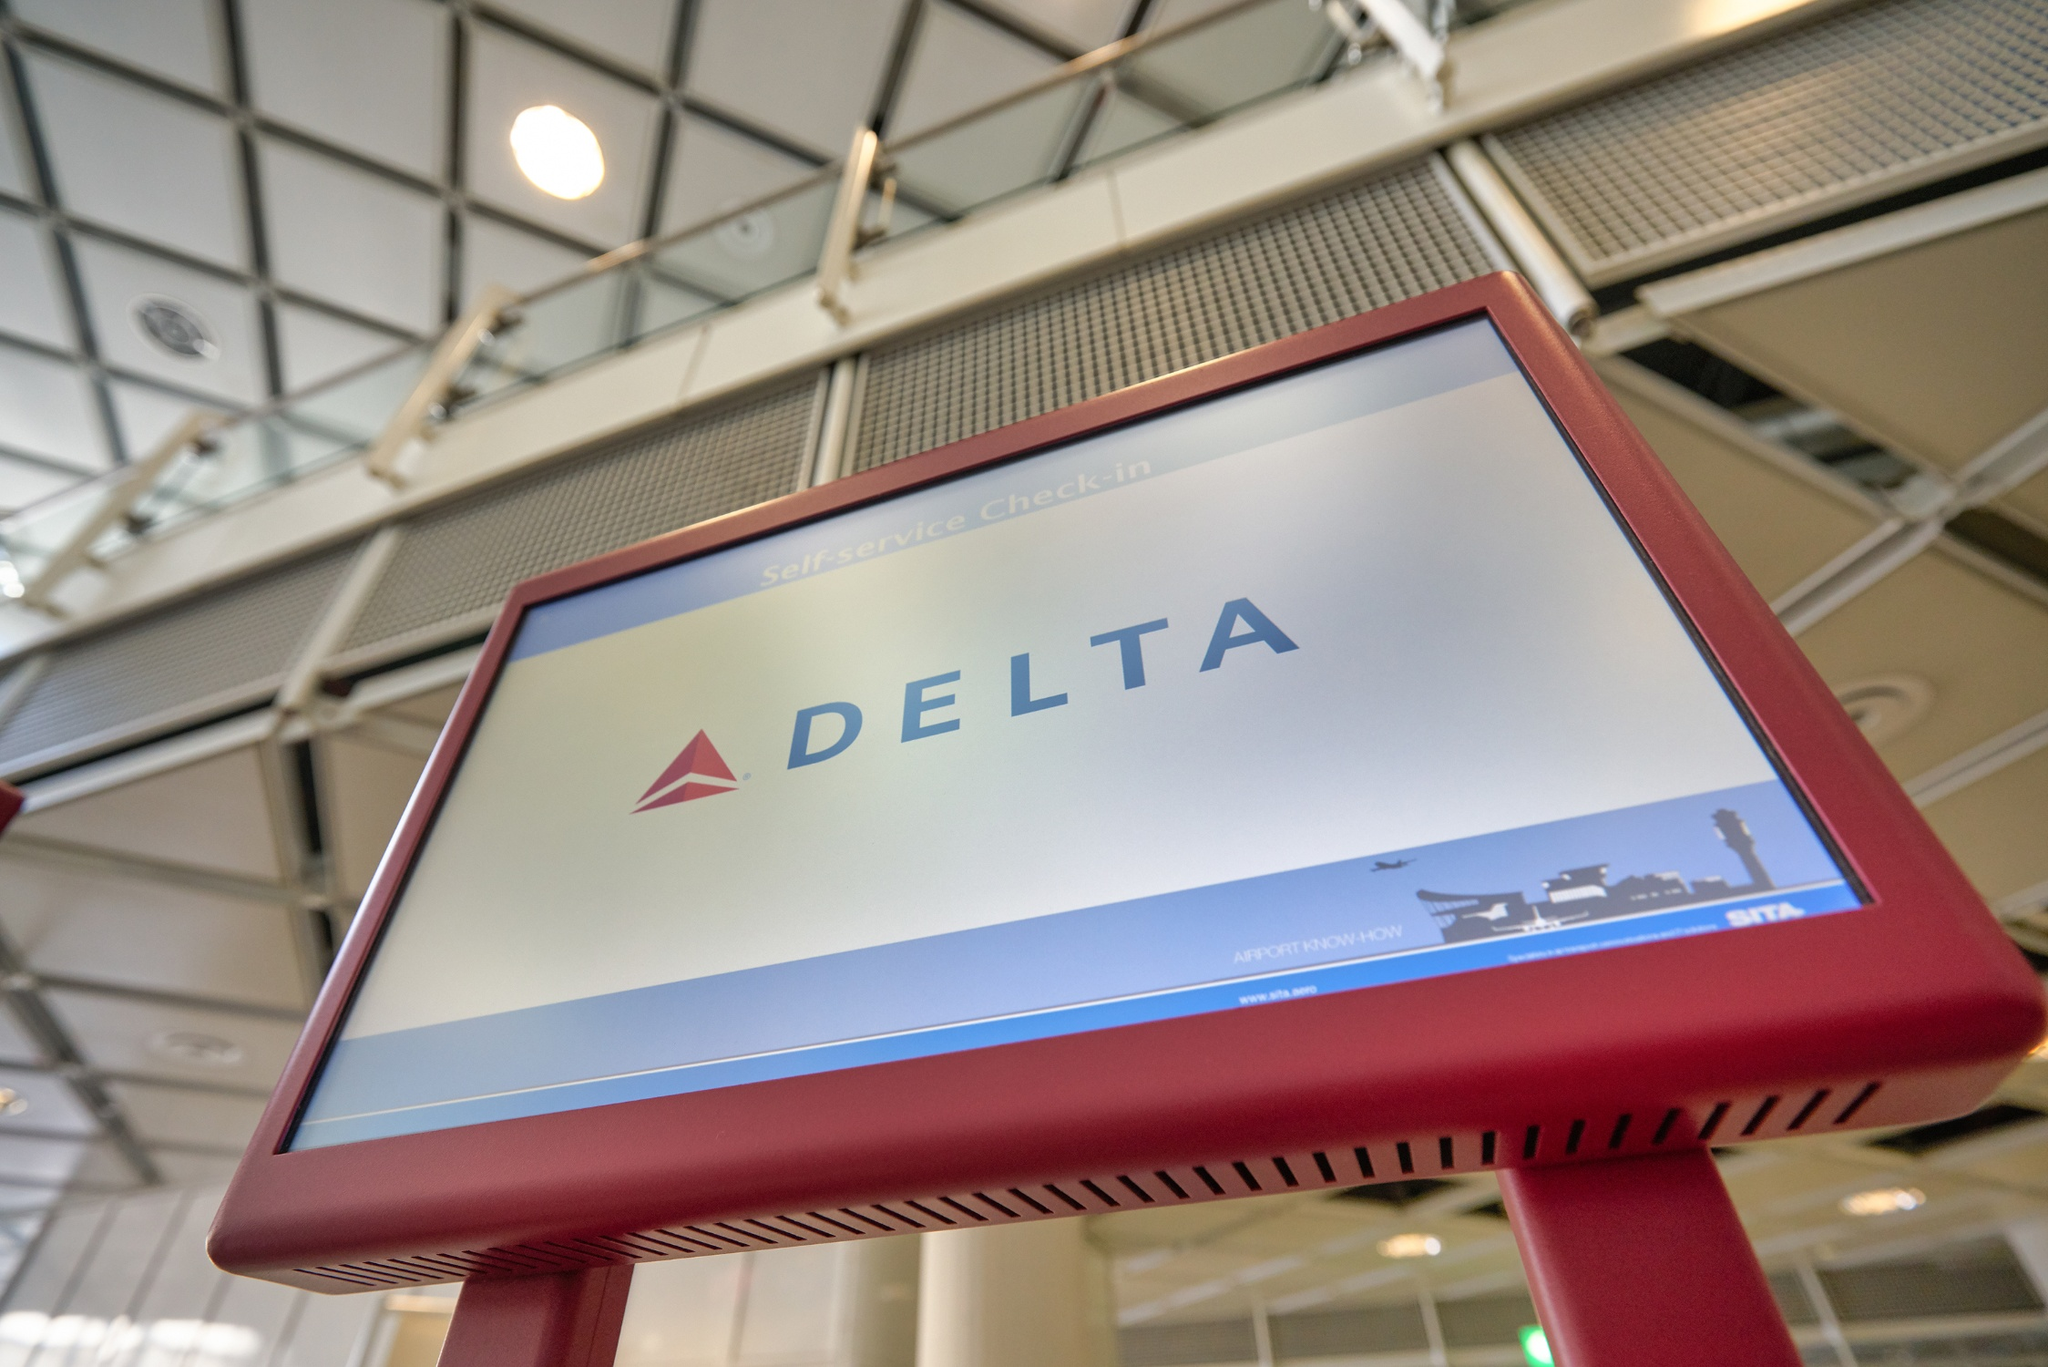If the check-in kiosks could talk, what unique feature stories might they share about their role in the airport? If the check-in kiosks could talk, they might share stories of the many travelers they’ve assisted, from families heading off on vacation to business people rushing to their next meeting. They could recount the evolving technology that has made them more user-friendly and efficient over the years. They might also detail how they have helped speed up the check-in process, reducing long lines at the check-in counters and allowing passengers more time to relax before their flights. They could even talk about memorable moments, such as helping someone check in during a particularly snowy holiday season, or aiding a traveler who was running late for an important trip. 